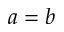<formula> <loc_0><loc_0><loc_500><loc_500>a = b</formula> 